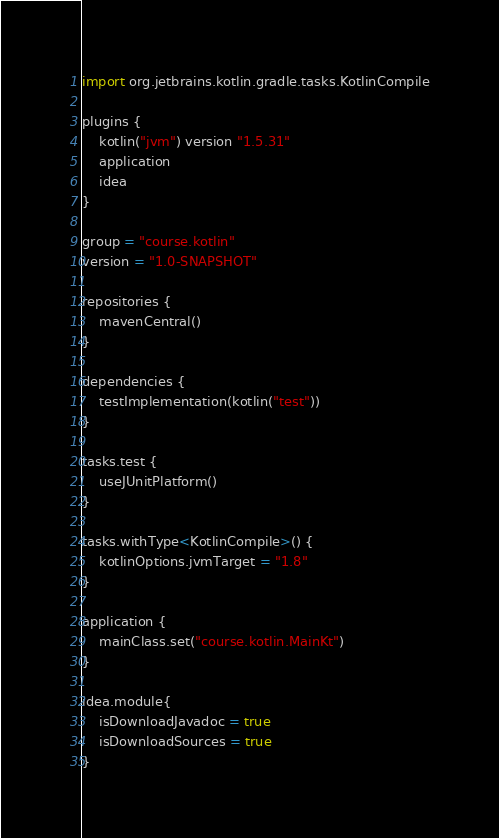<code> <loc_0><loc_0><loc_500><loc_500><_Kotlin_>import org.jetbrains.kotlin.gradle.tasks.KotlinCompile

plugins {
    kotlin("jvm") version "1.5.31"
    application
    idea
}

group = "course.kotlin"
version = "1.0-SNAPSHOT"

repositories {
    mavenCentral()
}

dependencies {
    testImplementation(kotlin("test"))
}

tasks.test {
    useJUnitPlatform()
}

tasks.withType<KotlinCompile>() {
    kotlinOptions.jvmTarget = "1.8"
}

application {
    mainClass.set("course.kotlin.MainKt")
}

idea.module{
    isDownloadJavadoc = true
    isDownloadSources = true
}
</code> 